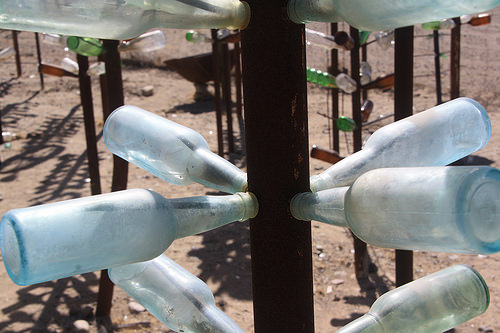<image>
Is the bottle on the metal rod? Yes. Looking at the image, I can see the bottle is positioned on top of the metal rod, with the metal rod providing support. 